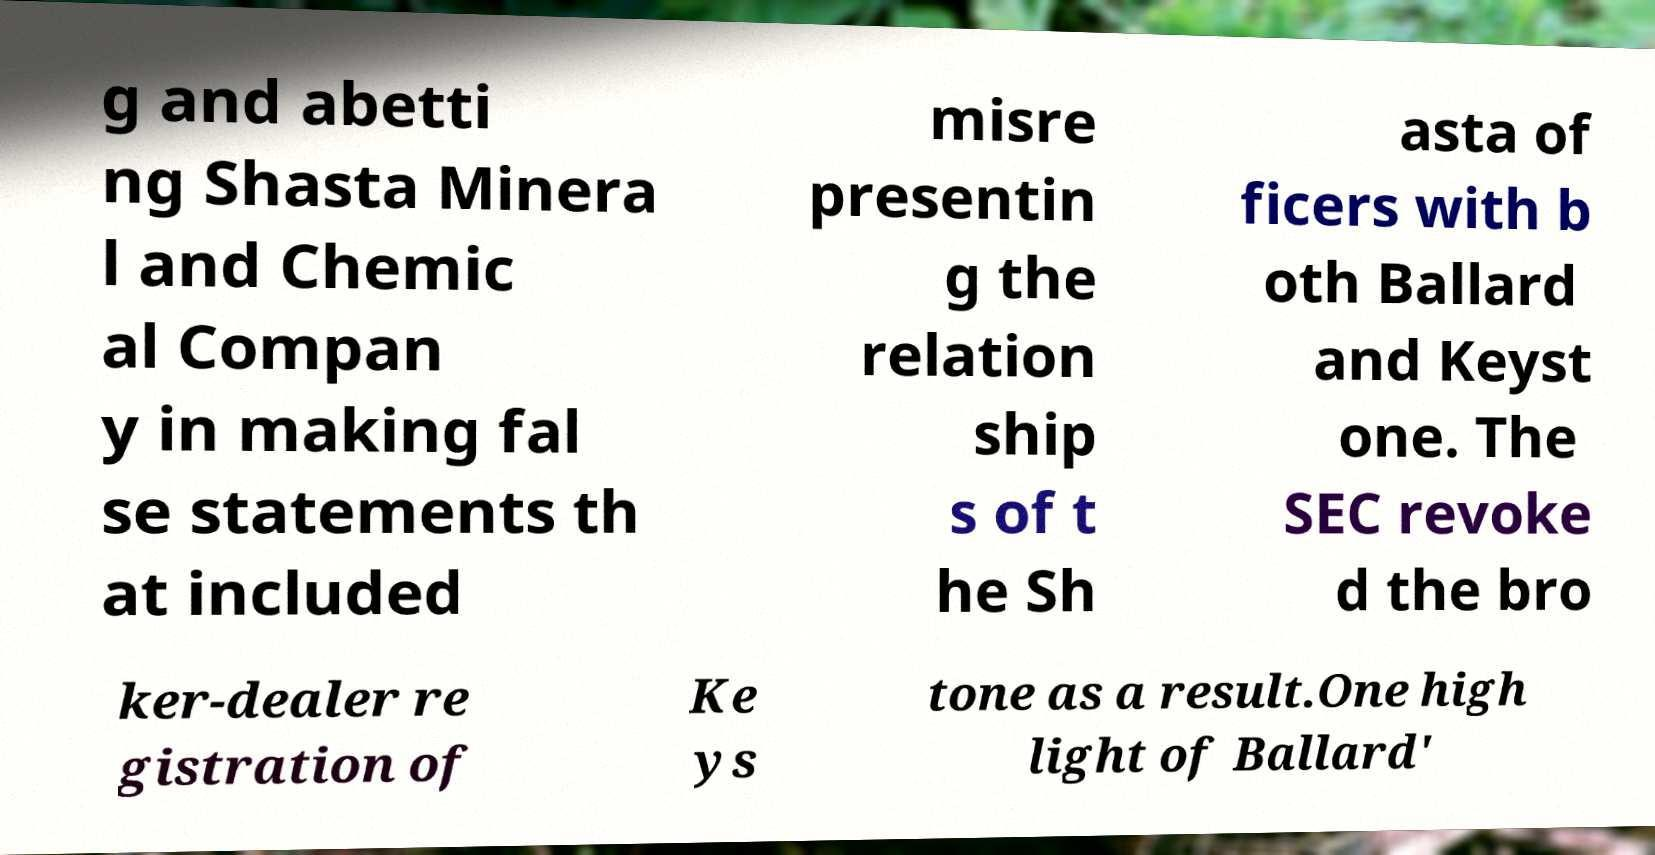Can you accurately transcribe the text from the provided image for me? g and abetti ng Shasta Minera l and Chemic al Compan y in making fal se statements th at included misre presentin g the relation ship s of t he Sh asta of ficers with b oth Ballard and Keyst one. The SEC revoke d the bro ker-dealer re gistration of Ke ys tone as a result.One high light of Ballard' 